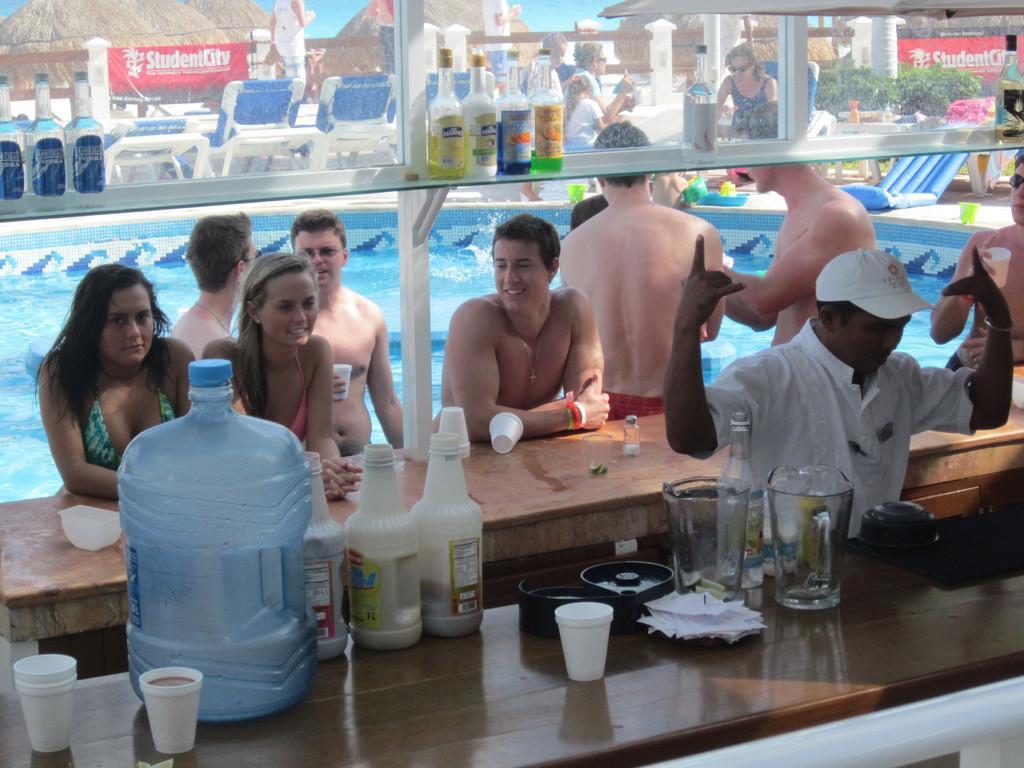In one or two sentences, can you explain what this image depicts? In this image we can see many people are in the swimming pool. Here we can see cups, a water can, bottles and jars on the table. In the background through glasses we can see huts and chairs. 